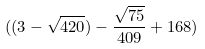<formula> <loc_0><loc_0><loc_500><loc_500>( ( 3 - \sqrt { 4 2 0 } ) - \frac { \sqrt { 7 5 } } { 4 0 9 } + 1 6 8 )</formula> 